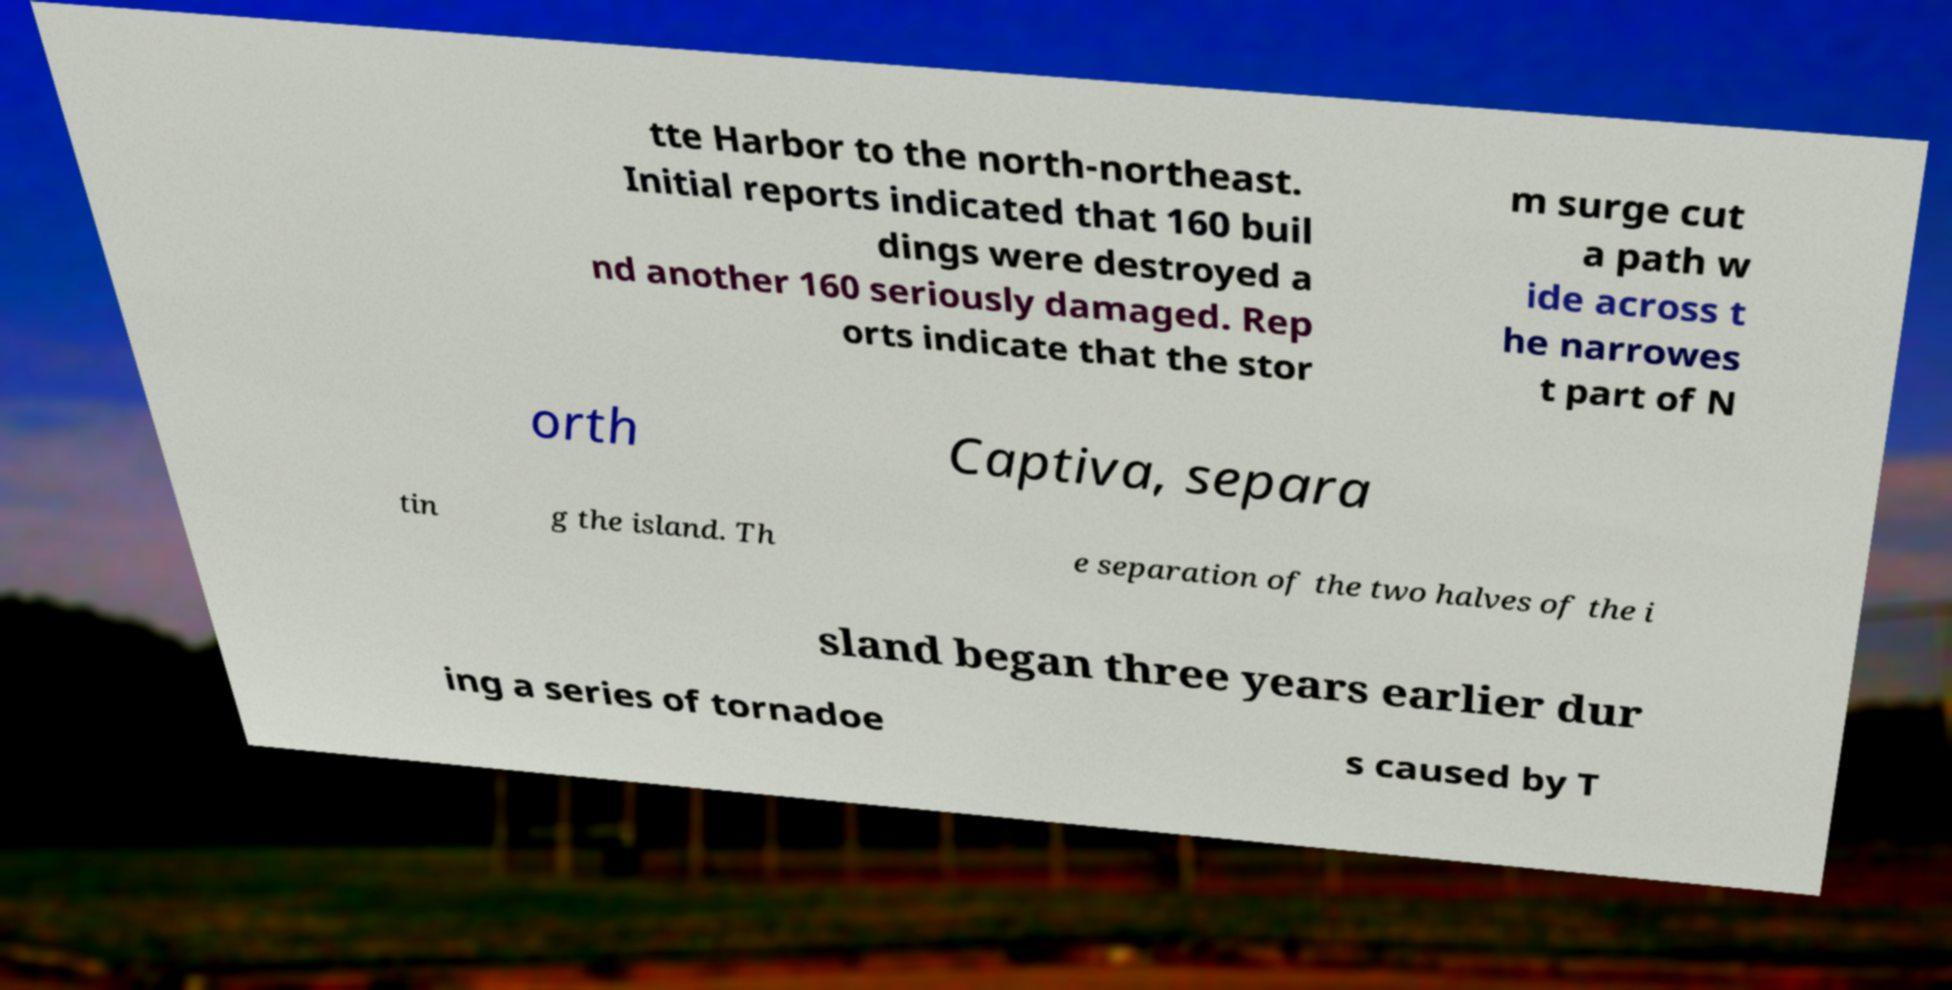For documentation purposes, I need the text within this image transcribed. Could you provide that? tte Harbor to the north-northeast. Initial reports indicated that 160 buil dings were destroyed a nd another 160 seriously damaged. Rep orts indicate that the stor m surge cut a path w ide across t he narrowes t part of N orth Captiva, separa tin g the island. Th e separation of the two halves of the i sland began three years earlier dur ing a series of tornadoe s caused by T 